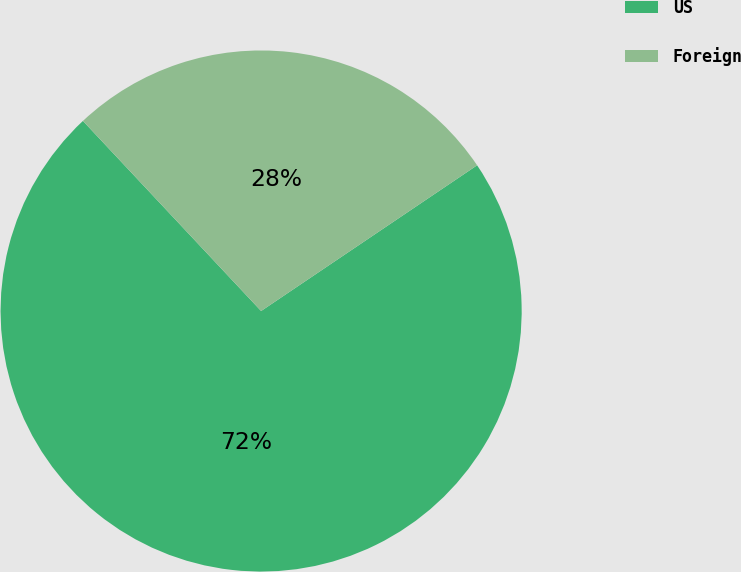Convert chart. <chart><loc_0><loc_0><loc_500><loc_500><pie_chart><fcel>US<fcel>Foreign<nl><fcel>72.46%<fcel>27.54%<nl></chart> 